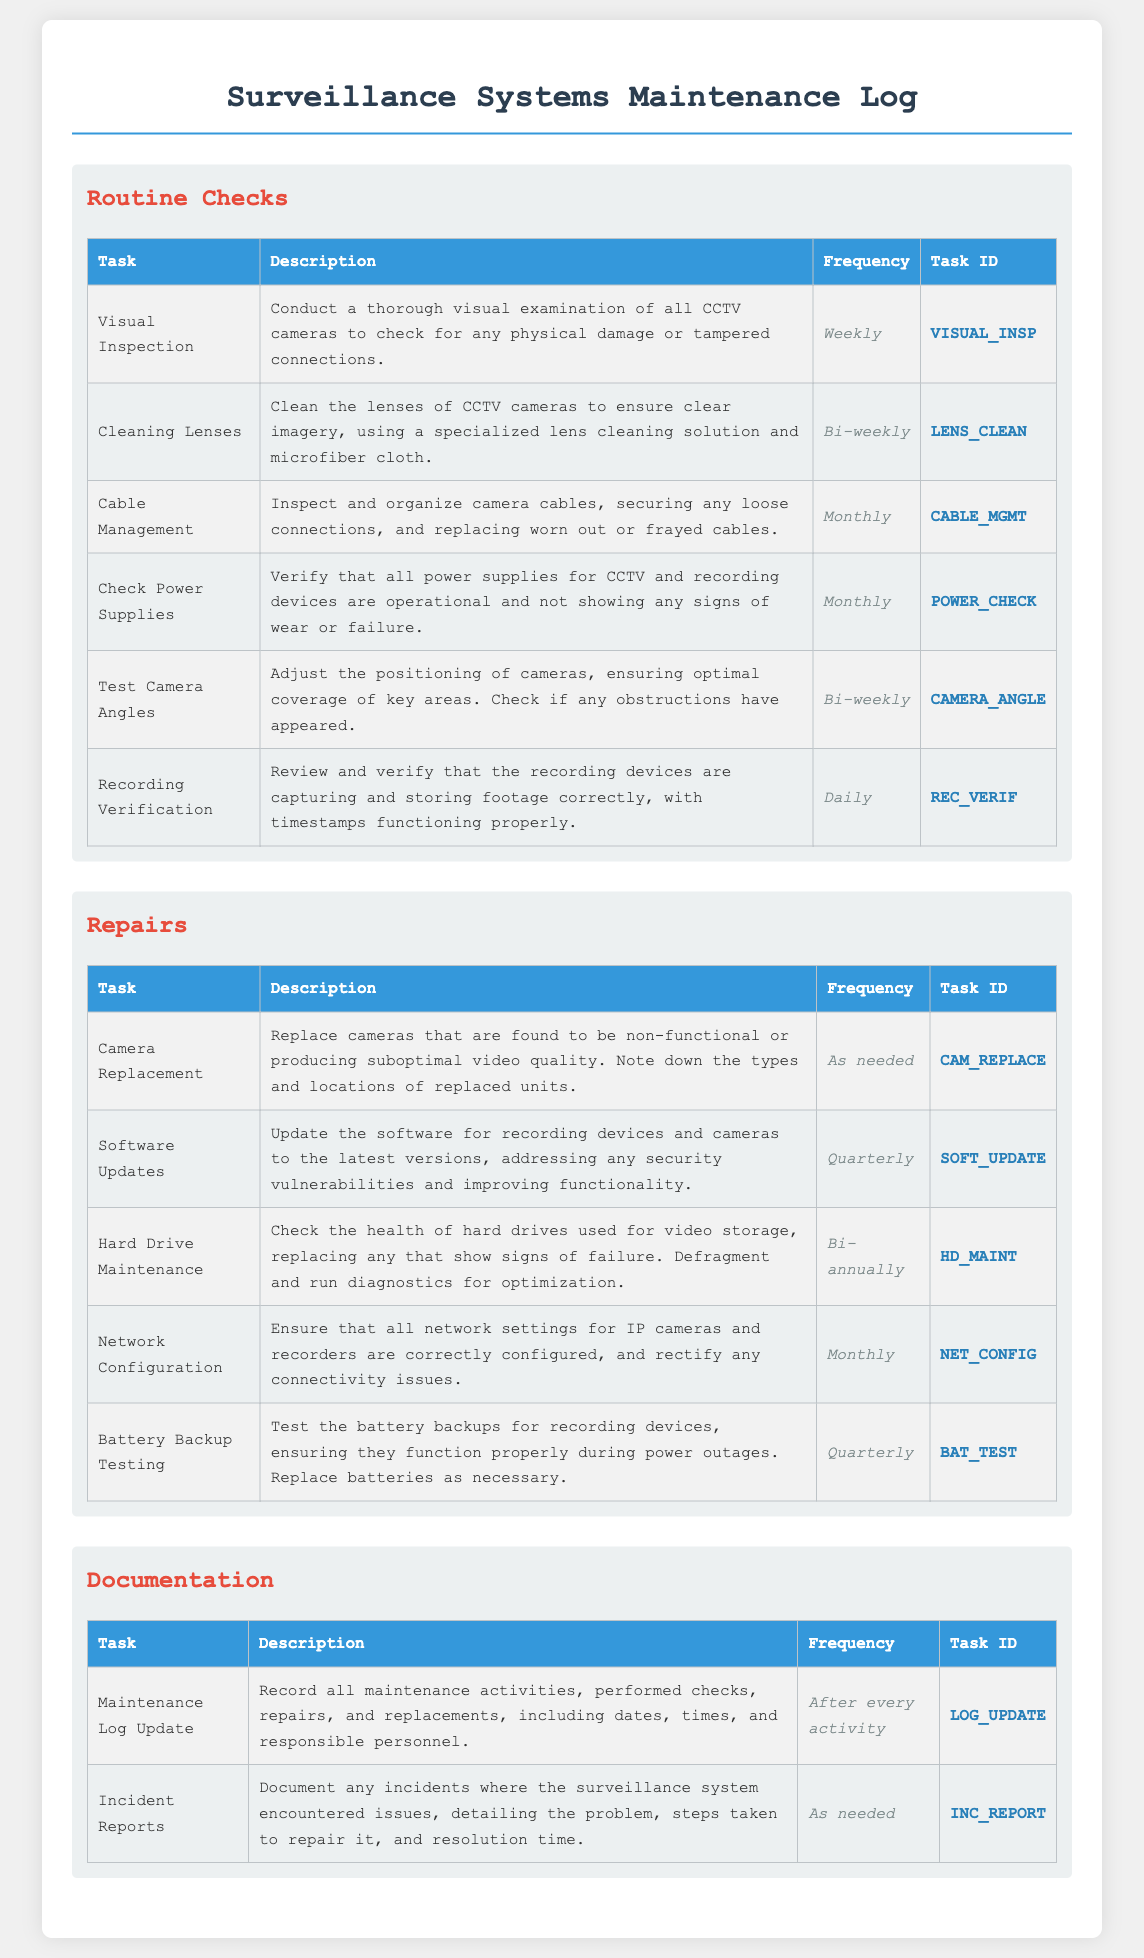What is the frequency of Visual Inspection? The frequency of Visual Inspection is stated in the document as Weekly.
Answer: Weekly How often should the lenses be cleaned? The frequency for cleaning lenses is clearly mentioned as Bi-weekly in the Routine Checks section.
Answer: Bi-weekly What task is performed after every activity? The task performed after every activity is updating the Maintenance Log, which is highlighted under Documentation.
Answer: Maintenance Log Update How many times a year should software updates be conducted? The document indicates that Software Updates should occur Quarterly, meaning 4 times a year.
Answer: Quarterly What is the task ID for the Cable Management process? The Task ID for Cable Management is listed as CABLE_MGMT in the Routine Checks section.
Answer: CABLE_MGMT Which task involves testing battery backups? The task involving testing battery backups is labeled as Battery Backup Testing in the Repairs category.
Answer: Battery Backup Testing How often should hard drive maintenance be performed? The frequency for Hard Drive Maintenance is stated as Bi-annually in the Repairs section.
Answer: Bi-annually What is recorded in Incident Reports? Incident Reports document any incidents with details about the problems and repairs, as designed in the Documentation section.
Answer: Incidents What is the frequency for checking power supplies? The document specifies that checking power supplies occurs Monthly in the Routine Checks category.
Answer: Monthly 